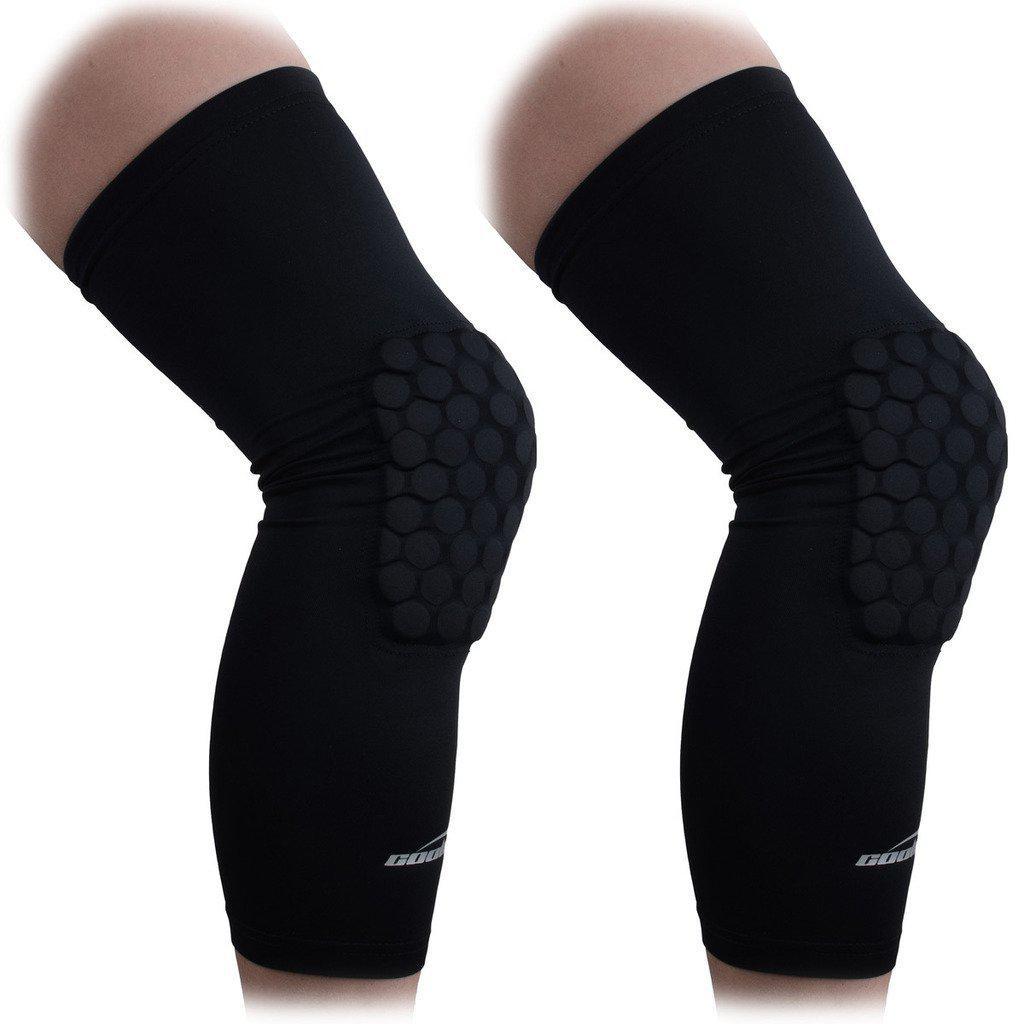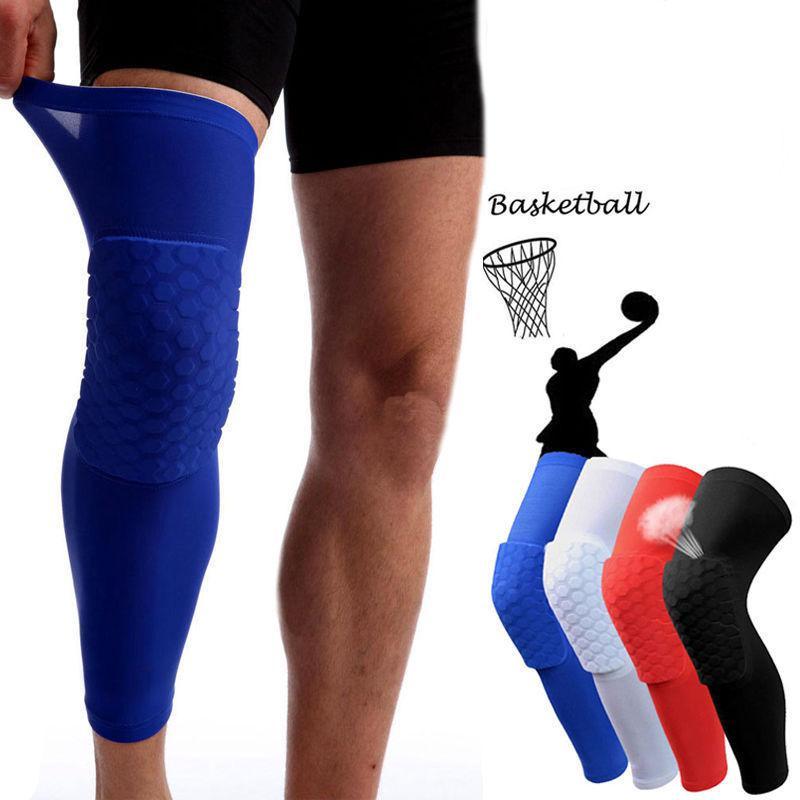The first image is the image on the left, the second image is the image on the right. For the images displayed, is the sentence "The left and right image contains a total of seven knee braces." factually correct? Answer yes or no. Yes. The first image is the image on the left, the second image is the image on the right. Examine the images to the left and right. Is the description "In the right image, only the leg on the left is wearing a knee wrap, and the pair of legs are in black shorts." accurate? Answer yes or no. Yes. 